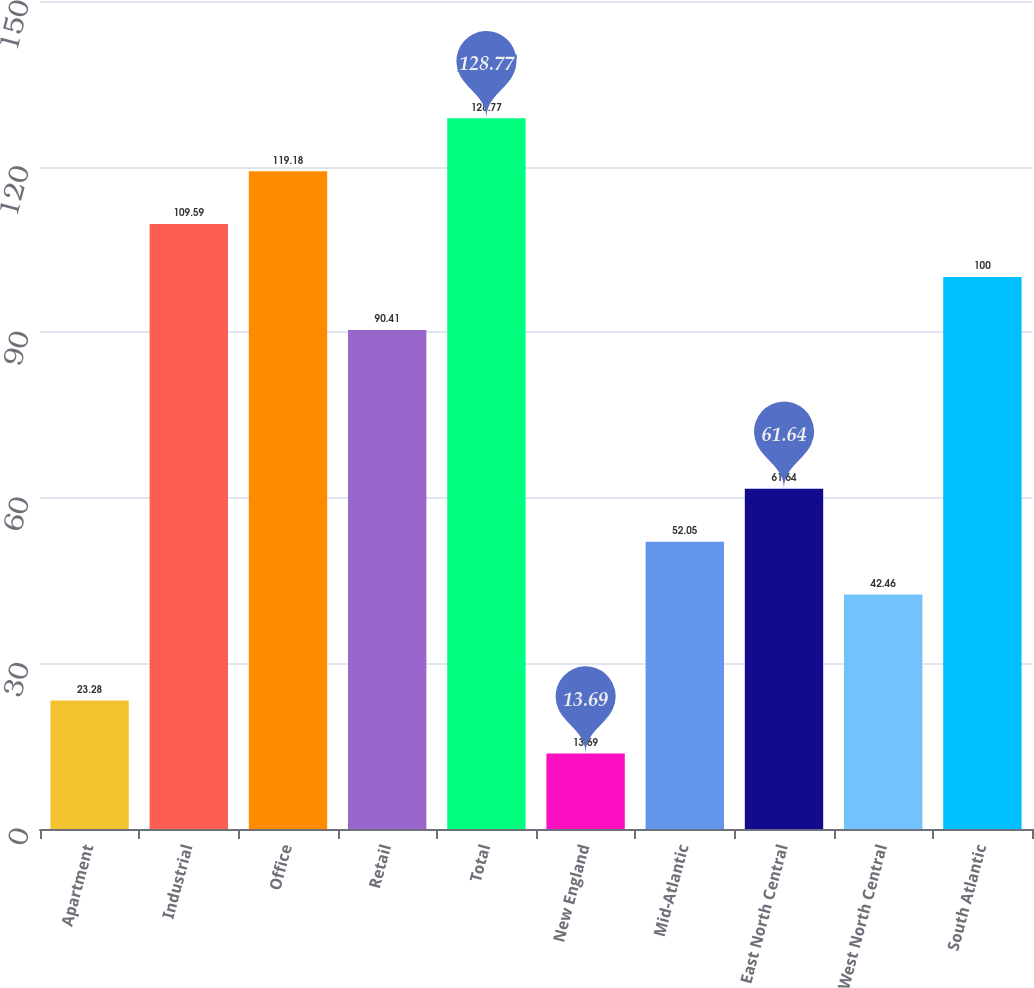Convert chart. <chart><loc_0><loc_0><loc_500><loc_500><bar_chart><fcel>Apartment<fcel>Industrial<fcel>Office<fcel>Retail<fcel>Total<fcel>New England<fcel>Mid-Atlantic<fcel>East North Central<fcel>West North Central<fcel>South Atlantic<nl><fcel>23.28<fcel>109.59<fcel>119.18<fcel>90.41<fcel>128.77<fcel>13.69<fcel>52.05<fcel>61.64<fcel>42.46<fcel>100<nl></chart> 